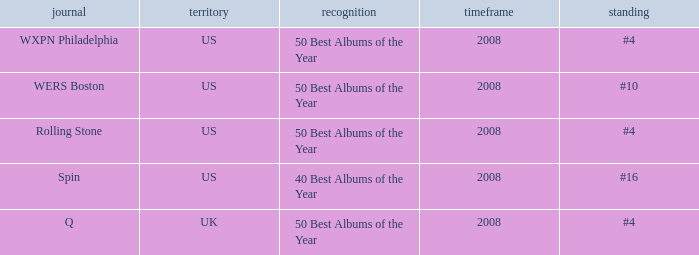In which place is the us situated when the distinction is the 40 best yearly albums? #16. 